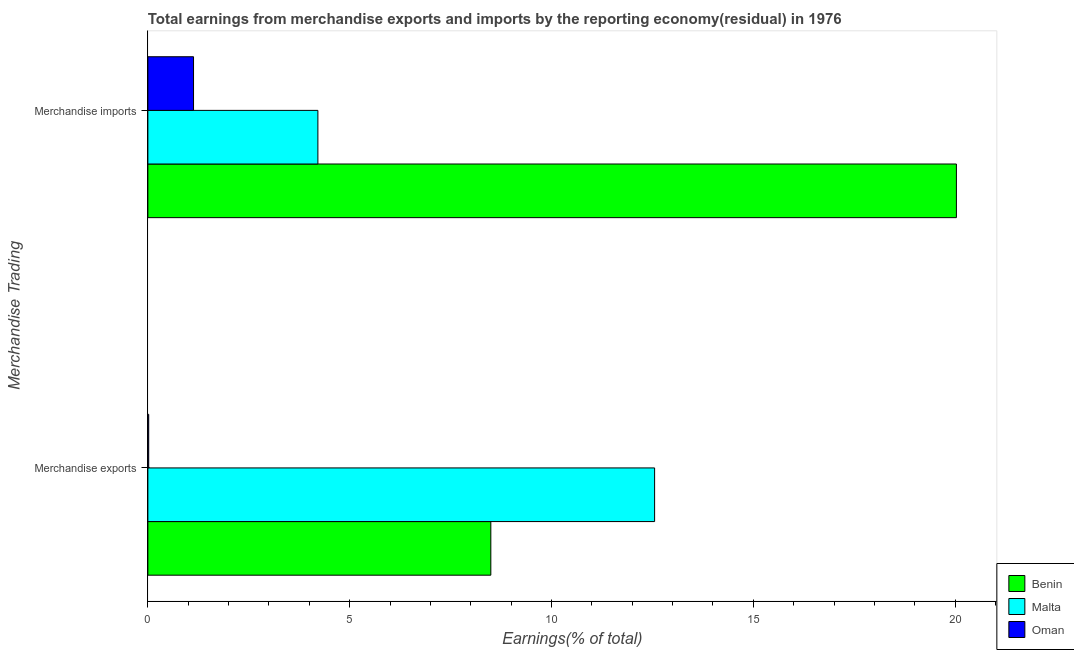How many bars are there on the 1st tick from the top?
Your response must be concise. 3. How many bars are there on the 2nd tick from the bottom?
Your answer should be compact. 3. What is the earnings from merchandise exports in Oman?
Provide a succinct answer. 0.02. Across all countries, what is the maximum earnings from merchandise exports?
Ensure brevity in your answer.  12.56. Across all countries, what is the minimum earnings from merchandise imports?
Your answer should be compact. 1.13. In which country was the earnings from merchandise exports maximum?
Offer a very short reply. Malta. In which country was the earnings from merchandise imports minimum?
Provide a short and direct response. Oman. What is the total earnings from merchandise imports in the graph?
Offer a terse response. 25.38. What is the difference between the earnings from merchandise exports in Benin and that in Malta?
Provide a succinct answer. -4.06. What is the difference between the earnings from merchandise imports in Benin and the earnings from merchandise exports in Oman?
Provide a succinct answer. 20.01. What is the average earnings from merchandise exports per country?
Ensure brevity in your answer.  7.02. What is the difference between the earnings from merchandise imports and earnings from merchandise exports in Benin?
Provide a short and direct response. 11.54. What is the ratio of the earnings from merchandise exports in Oman to that in Malta?
Give a very brief answer. 0. Is the earnings from merchandise imports in Malta less than that in Oman?
Provide a short and direct response. No. What does the 1st bar from the top in Merchandise exports represents?
Your answer should be very brief. Oman. What does the 1st bar from the bottom in Merchandise exports represents?
Offer a terse response. Benin. How many bars are there?
Your response must be concise. 6. What is the difference between two consecutive major ticks on the X-axis?
Give a very brief answer. 5. Are the values on the major ticks of X-axis written in scientific E-notation?
Ensure brevity in your answer.  No. Where does the legend appear in the graph?
Your response must be concise. Bottom right. How many legend labels are there?
Give a very brief answer. 3. How are the legend labels stacked?
Provide a short and direct response. Vertical. What is the title of the graph?
Make the answer very short. Total earnings from merchandise exports and imports by the reporting economy(residual) in 1976. Does "Belize" appear as one of the legend labels in the graph?
Your answer should be very brief. No. What is the label or title of the X-axis?
Keep it short and to the point. Earnings(% of total). What is the label or title of the Y-axis?
Provide a succinct answer. Merchandise Trading. What is the Earnings(% of total) of Benin in Merchandise exports?
Your response must be concise. 8.5. What is the Earnings(% of total) of Malta in Merchandise exports?
Keep it short and to the point. 12.56. What is the Earnings(% of total) in Oman in Merchandise exports?
Provide a succinct answer. 0.02. What is the Earnings(% of total) of Benin in Merchandise imports?
Give a very brief answer. 20.03. What is the Earnings(% of total) in Malta in Merchandise imports?
Provide a short and direct response. 4.21. What is the Earnings(% of total) in Oman in Merchandise imports?
Offer a terse response. 1.13. Across all Merchandise Trading, what is the maximum Earnings(% of total) of Benin?
Give a very brief answer. 20.03. Across all Merchandise Trading, what is the maximum Earnings(% of total) of Malta?
Your answer should be very brief. 12.56. Across all Merchandise Trading, what is the maximum Earnings(% of total) of Oman?
Your response must be concise. 1.13. Across all Merchandise Trading, what is the minimum Earnings(% of total) in Benin?
Your answer should be very brief. 8.5. Across all Merchandise Trading, what is the minimum Earnings(% of total) in Malta?
Give a very brief answer. 4.21. Across all Merchandise Trading, what is the minimum Earnings(% of total) of Oman?
Your answer should be compact. 0.02. What is the total Earnings(% of total) of Benin in the graph?
Your answer should be compact. 28.53. What is the total Earnings(% of total) in Malta in the graph?
Make the answer very short. 16.77. What is the total Earnings(% of total) of Oman in the graph?
Keep it short and to the point. 1.15. What is the difference between the Earnings(% of total) in Benin in Merchandise exports and that in Merchandise imports?
Offer a terse response. -11.54. What is the difference between the Earnings(% of total) in Malta in Merchandise exports and that in Merchandise imports?
Your answer should be very brief. 8.34. What is the difference between the Earnings(% of total) of Oman in Merchandise exports and that in Merchandise imports?
Give a very brief answer. -1.11. What is the difference between the Earnings(% of total) of Benin in Merchandise exports and the Earnings(% of total) of Malta in Merchandise imports?
Offer a very short reply. 4.28. What is the difference between the Earnings(% of total) of Benin in Merchandise exports and the Earnings(% of total) of Oman in Merchandise imports?
Make the answer very short. 7.37. What is the difference between the Earnings(% of total) of Malta in Merchandise exports and the Earnings(% of total) of Oman in Merchandise imports?
Provide a short and direct response. 11.42. What is the average Earnings(% of total) in Benin per Merchandise Trading?
Ensure brevity in your answer.  14.26. What is the average Earnings(% of total) in Malta per Merchandise Trading?
Your answer should be very brief. 8.38. What is the average Earnings(% of total) of Oman per Merchandise Trading?
Ensure brevity in your answer.  0.58. What is the difference between the Earnings(% of total) of Benin and Earnings(% of total) of Malta in Merchandise exports?
Your answer should be compact. -4.06. What is the difference between the Earnings(% of total) in Benin and Earnings(% of total) in Oman in Merchandise exports?
Make the answer very short. 8.48. What is the difference between the Earnings(% of total) of Malta and Earnings(% of total) of Oman in Merchandise exports?
Offer a very short reply. 12.53. What is the difference between the Earnings(% of total) in Benin and Earnings(% of total) in Malta in Merchandise imports?
Give a very brief answer. 15.82. What is the difference between the Earnings(% of total) of Benin and Earnings(% of total) of Oman in Merchandise imports?
Provide a short and direct response. 18.9. What is the difference between the Earnings(% of total) in Malta and Earnings(% of total) in Oman in Merchandise imports?
Give a very brief answer. 3.08. What is the ratio of the Earnings(% of total) in Benin in Merchandise exports to that in Merchandise imports?
Ensure brevity in your answer.  0.42. What is the ratio of the Earnings(% of total) of Malta in Merchandise exports to that in Merchandise imports?
Provide a short and direct response. 2.98. What is the ratio of the Earnings(% of total) of Oman in Merchandise exports to that in Merchandise imports?
Give a very brief answer. 0.02. What is the difference between the highest and the second highest Earnings(% of total) in Benin?
Provide a short and direct response. 11.54. What is the difference between the highest and the second highest Earnings(% of total) of Malta?
Ensure brevity in your answer.  8.34. What is the difference between the highest and the second highest Earnings(% of total) in Oman?
Offer a very short reply. 1.11. What is the difference between the highest and the lowest Earnings(% of total) in Benin?
Your answer should be very brief. 11.54. What is the difference between the highest and the lowest Earnings(% of total) in Malta?
Give a very brief answer. 8.34. What is the difference between the highest and the lowest Earnings(% of total) in Oman?
Provide a succinct answer. 1.11. 